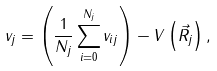<formula> <loc_0><loc_0><loc_500><loc_500>v _ { j } = \left ( \frac { 1 } { N _ { j } } \sum ^ { N _ { j } } _ { i = 0 } v _ { i j } \right ) - V \left ( \vec { R } _ { j } \right ) ,</formula> 